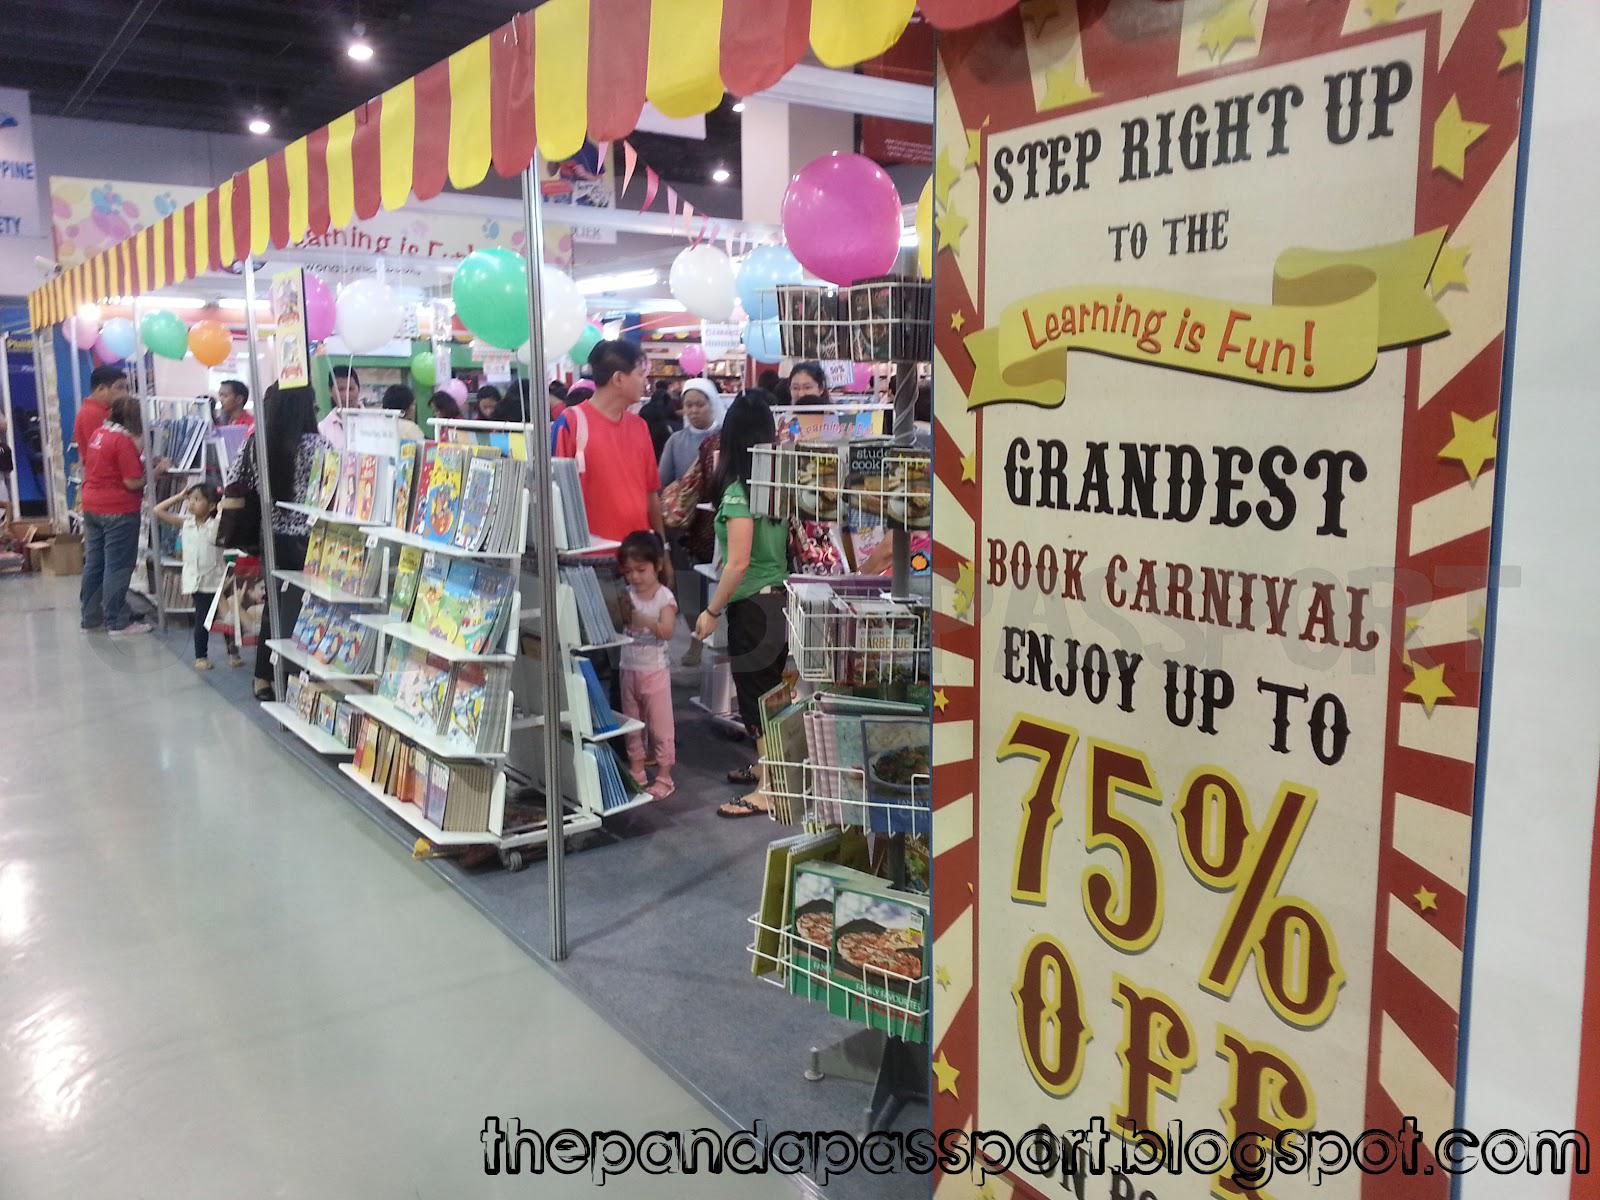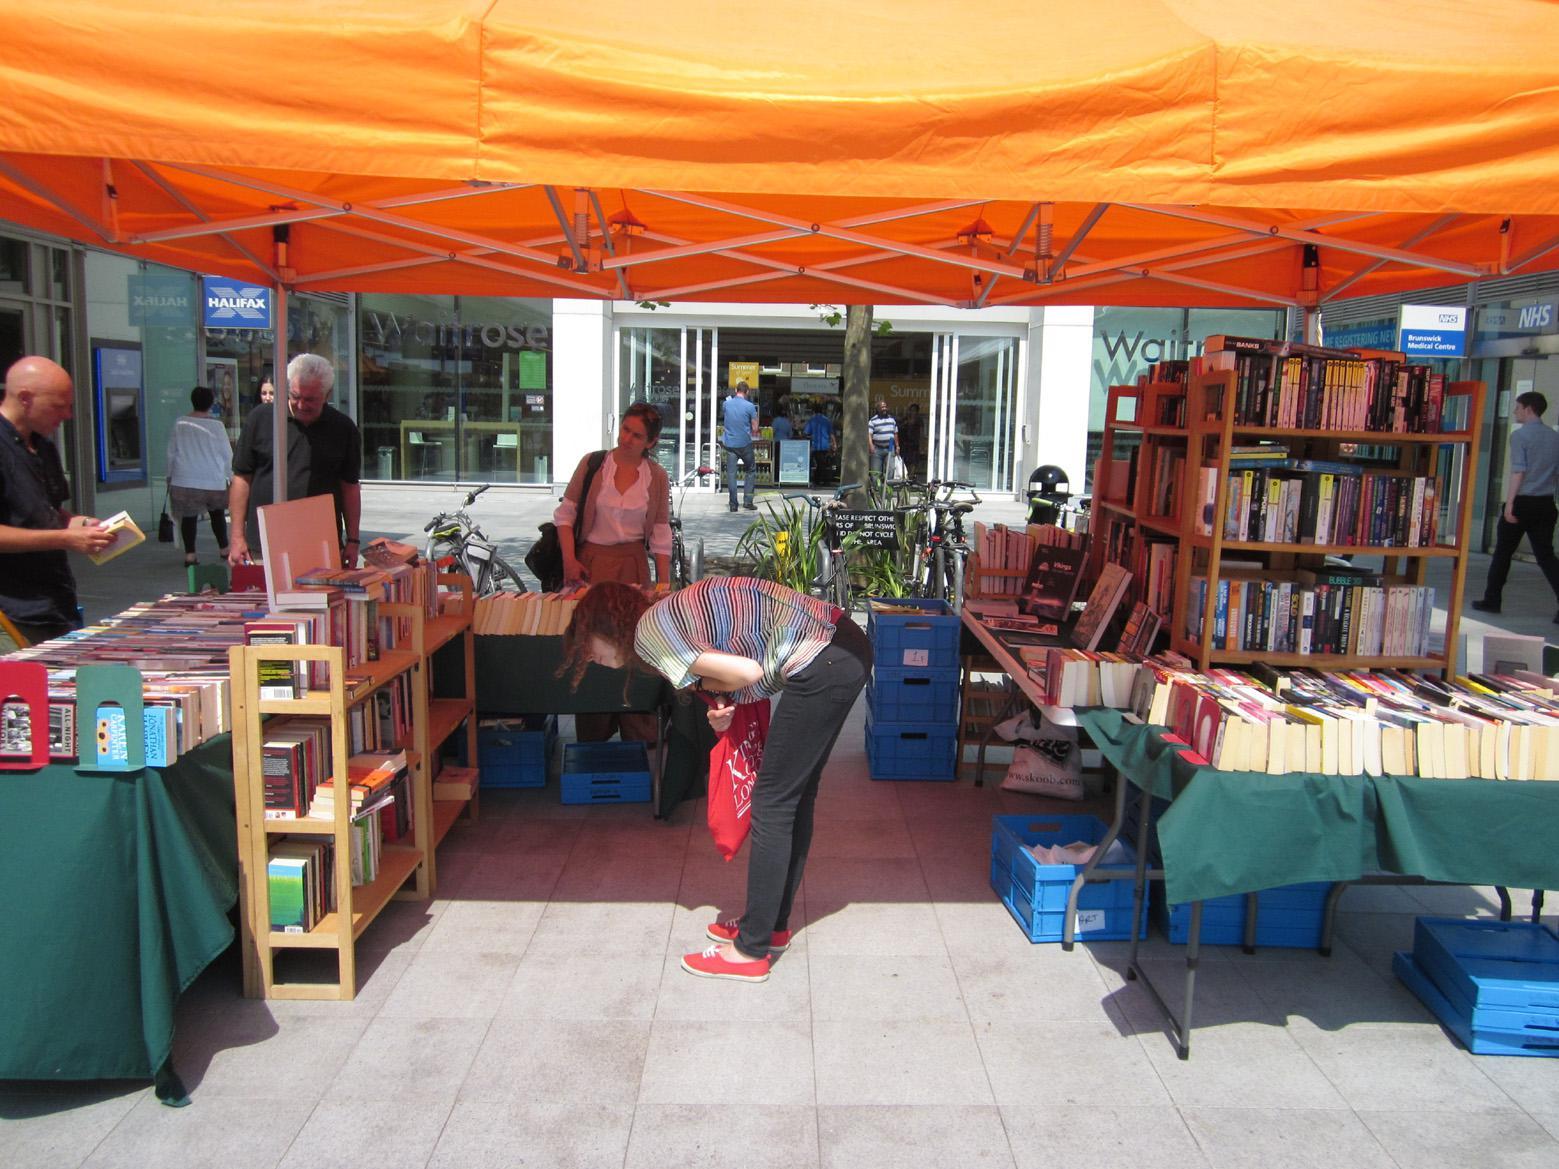The first image is the image on the left, the second image is the image on the right. Evaluate the accuracy of this statement regarding the images: "The left image includes a standing blue display with an S shape in a circle somewhere above it.". Is it true? Answer yes or no. No. The first image is the image on the left, the second image is the image on the right. Assess this claim about the two images: "In at least one image there is a person sitting on a chair looking at the desk in a kiosk.". Correct or not? Answer yes or no. No. 